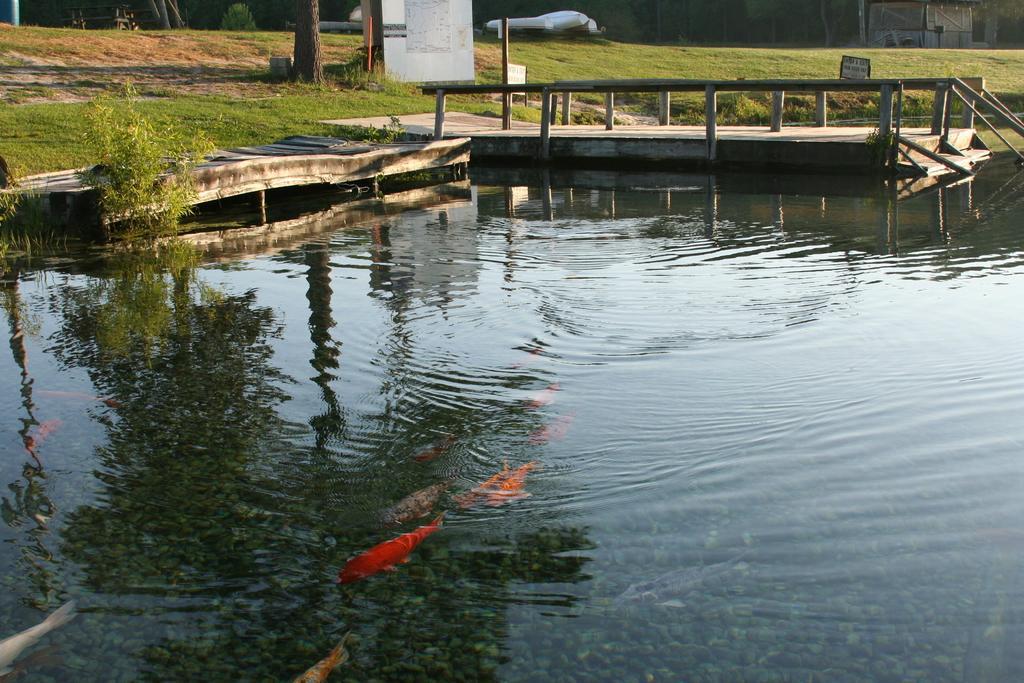Could you give a brief overview of what you see in this image? In this image I can see the water and I can see few aquatic animals in the water and they are in multi color. Background I can see the bridge, plants in green color and I can also see the board in white color. 